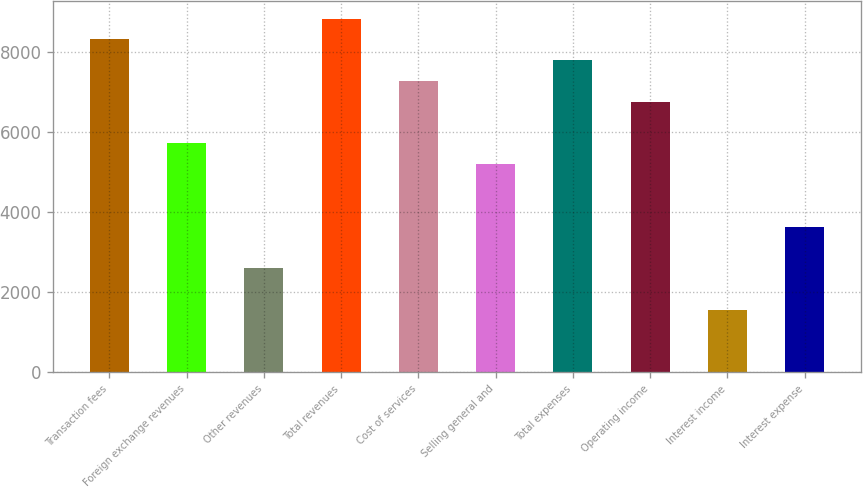Convert chart to OTSL. <chart><loc_0><loc_0><loc_500><loc_500><bar_chart><fcel>Transaction fees<fcel>Foreign exchange revenues<fcel>Other revenues<fcel>Total revenues<fcel>Cost of services<fcel>Selling general and<fcel>Total expenses<fcel>Operating income<fcel>Interest income<fcel>Interest expense<nl><fcel>8307.44<fcel>5711.79<fcel>2597.01<fcel>8826.57<fcel>7269.18<fcel>5192.66<fcel>7788.31<fcel>6750.05<fcel>1558.75<fcel>3635.27<nl></chart> 